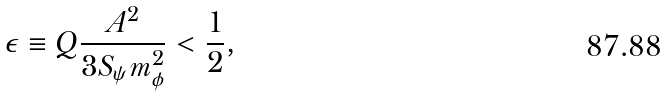Convert formula to latex. <formula><loc_0><loc_0><loc_500><loc_500>\epsilon \equiv Q \frac { A ^ { 2 } } { 3 S _ { \psi } m _ { \phi } ^ { 2 } } < \frac { 1 } { 2 } ,</formula> 